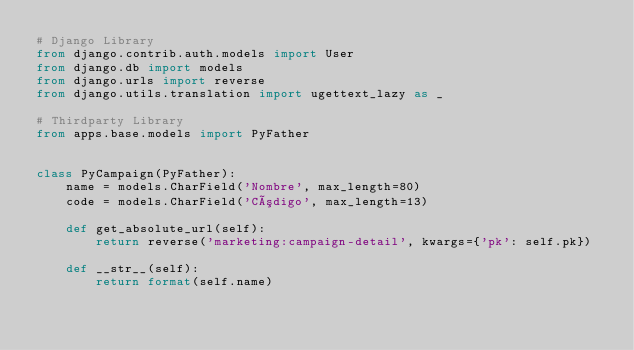Convert code to text. <code><loc_0><loc_0><loc_500><loc_500><_Python_># Django Library
from django.contrib.auth.models import User
from django.db import models
from django.urls import reverse
from django.utils.translation import ugettext_lazy as _

# Thirdparty Library
from apps.base.models import PyFather


class PyCampaign(PyFather):
    name = models.CharField('Nombre', max_length=80)
    code = models.CharField('Código', max_length=13)

    def get_absolute_url(self):
        return reverse('marketing:campaign-detail', kwargs={'pk': self.pk})

    def __str__(self):
        return format(self.name)
</code> 